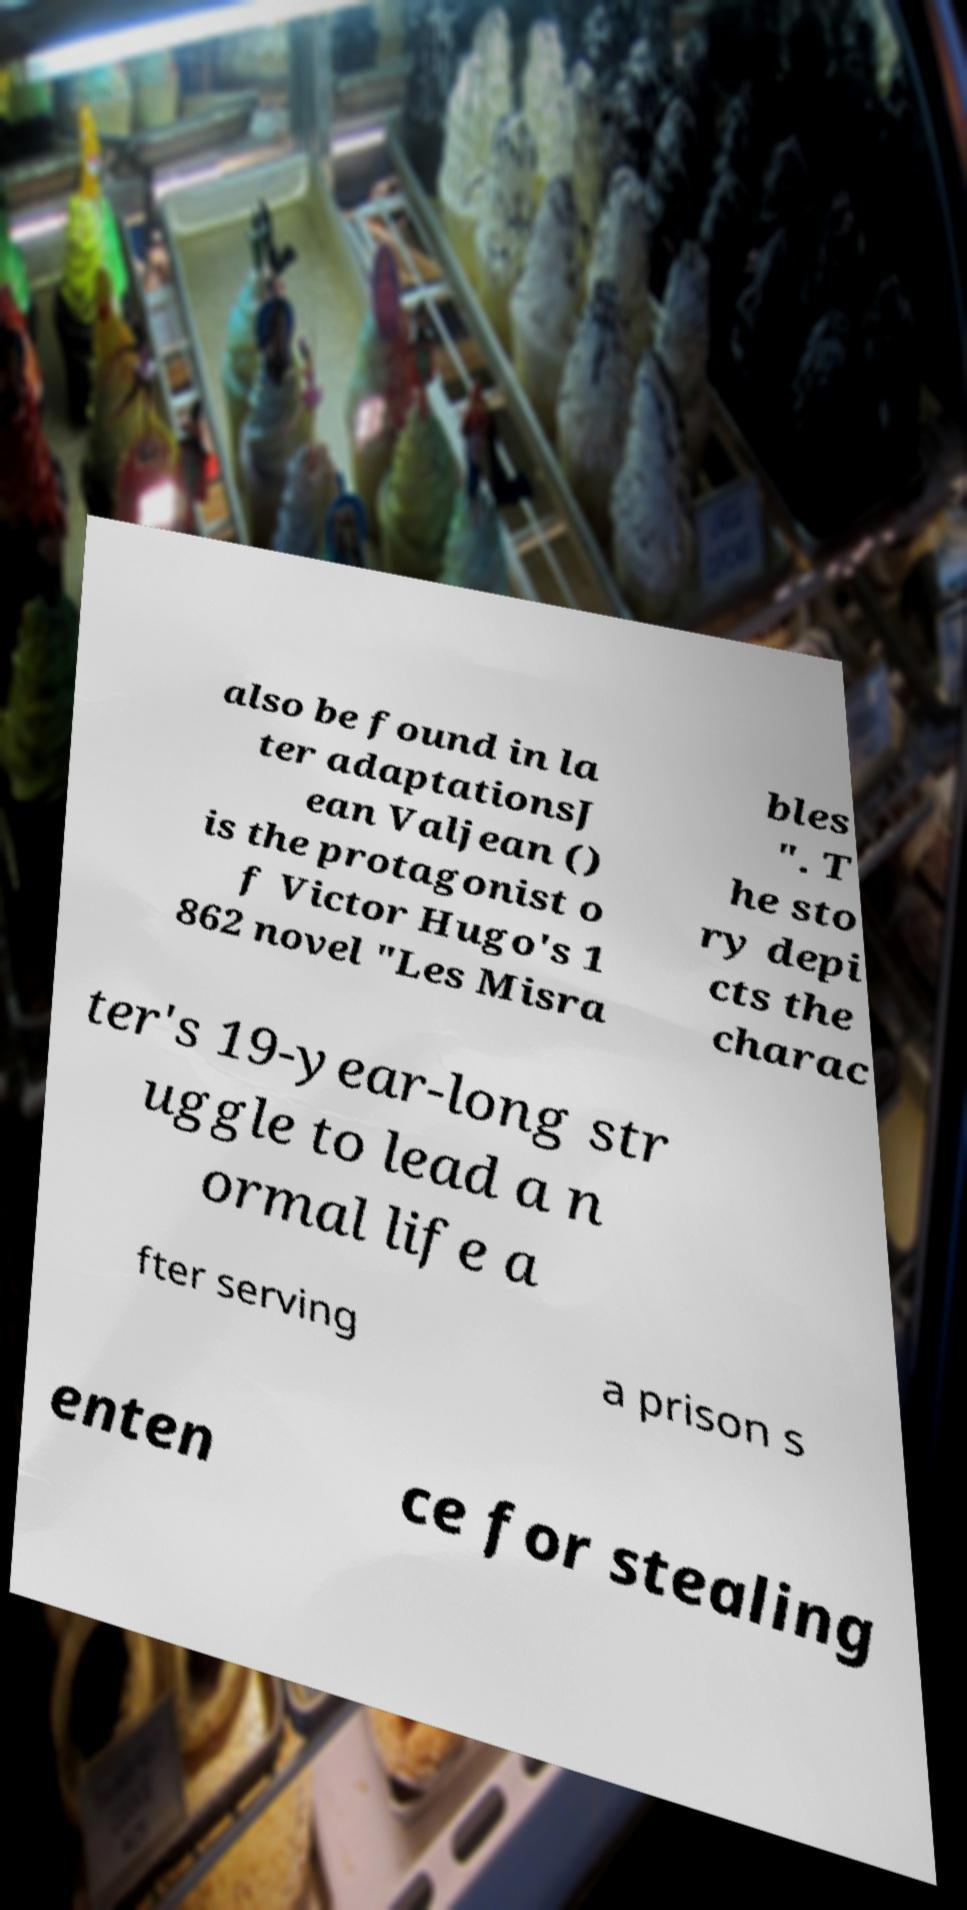There's text embedded in this image that I need extracted. Can you transcribe it verbatim? also be found in la ter adaptationsJ ean Valjean () is the protagonist o f Victor Hugo's 1 862 novel "Les Misra bles ". T he sto ry depi cts the charac ter's 19-year-long str uggle to lead a n ormal life a fter serving a prison s enten ce for stealing 